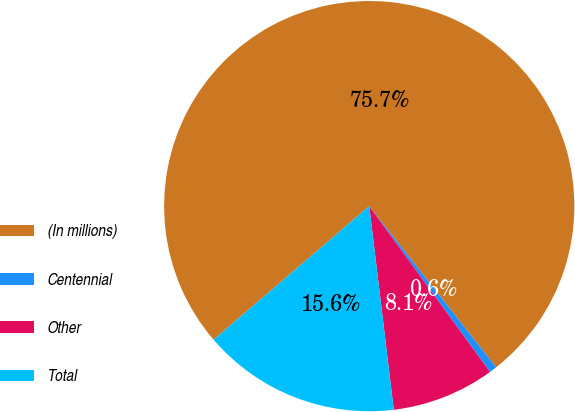<chart> <loc_0><loc_0><loc_500><loc_500><pie_chart><fcel>(In millions)<fcel>Centennial<fcel>Other<fcel>Total<nl><fcel>75.67%<fcel>0.6%<fcel>8.11%<fcel>15.62%<nl></chart> 